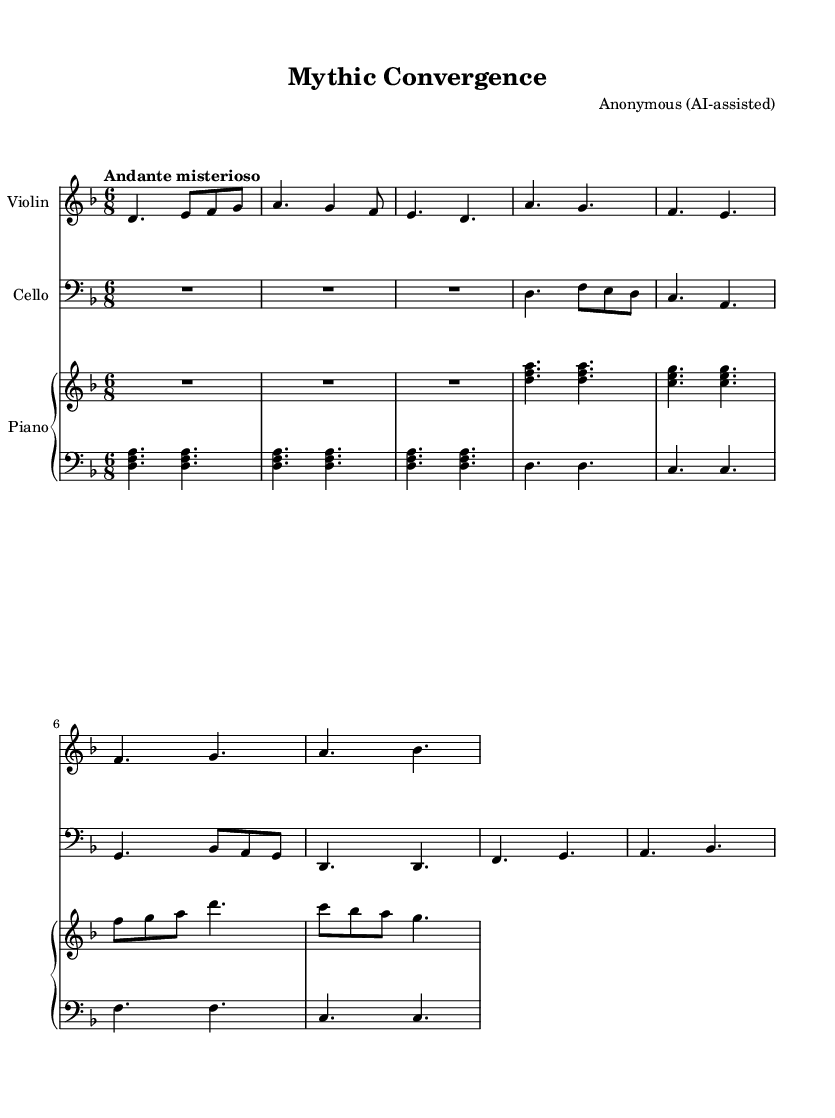What is the key signature of this music? The key signature is indicated at the beginning of the sheet music. In this case, it shows one flat, which indicates that it is in the key of D minor.
Answer: D minor What is the time signature of this music? The time signature is shown at the beginning of the piece. It is written as "6/8," which means there are six eighth notes per measure.
Answer: 6/8 What is the tempo marking for this piece? The tempo marking appears at the start of the music, described as "Andante misterioso," which translates to a moderately slow and mysterious pace of music.
Answer: Andante misterioso How many measures are included in Theme A for the violin? Counting the measures that are labeled as Theme A in the violin part, there are 4 measures, indicated by the sequence of notes.
Answer: 4 What is the harmonic structure used in the piano's upper staff during Theme A? In Theme A of the piano's upper staff, the chords are structured with the notes D, F, and A, along with C, E, and G. This highlights a triadic harmony characteristic of Romantic music.
Answer: Triadic harmony Which instrument plays the bass line? The bass line is played by the lower piano staff, which uses sounds lower than the treble clef while providing a harmonic foundation for the other instruments.
Answer: Piano (lower staff) What is the overall mood suggested by the piece's title and tempo? The title "Mythic Convergence" along with the tempo marking "Andante misterioso" signifies that the piece conveys a mysterious and contemplative atmosphere, likely connecting to the themes of mythology and storytelling.
Answer: Mysterious atmosphere 